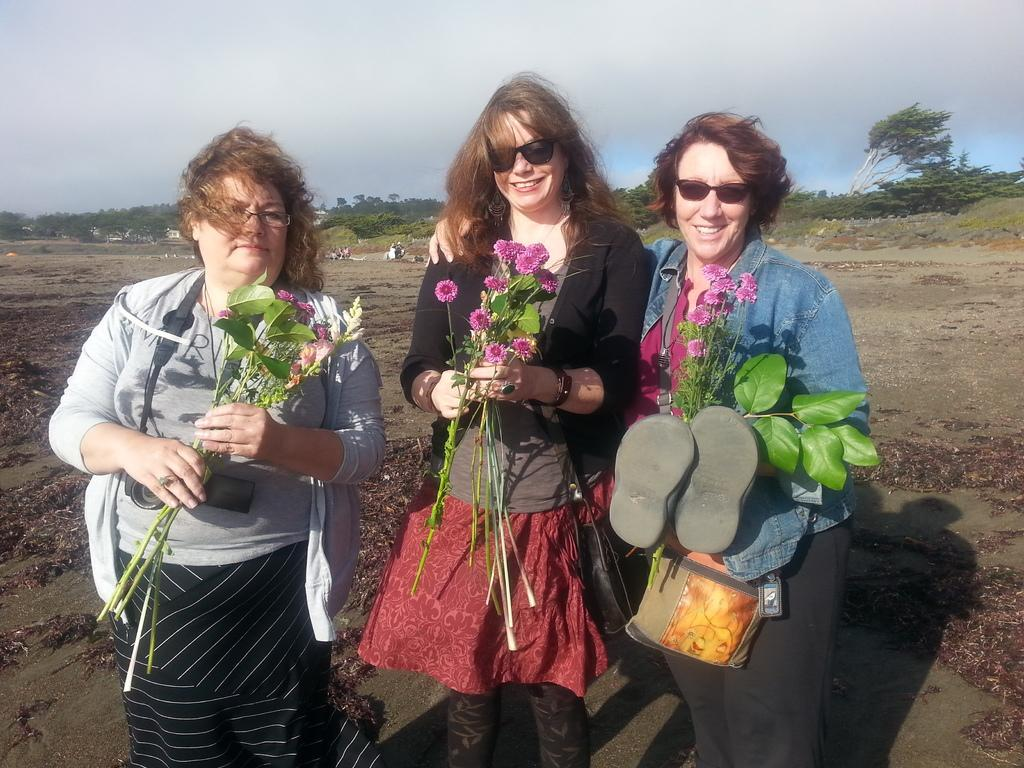How many ladies are present in the image? There are three ladies in the image. What are the ladies doing in the image? The ladies are standing and holding flowers. Is there anything else in the hands of one of the ladies? Yes, one lady is holding slippers. What can be seen in the background of the image? There are trees and the sky visible in the background of the image. What type of reaction can be seen on the stove in the image? There is no stove present in the image, so it is not possible to observe any reaction on it. 